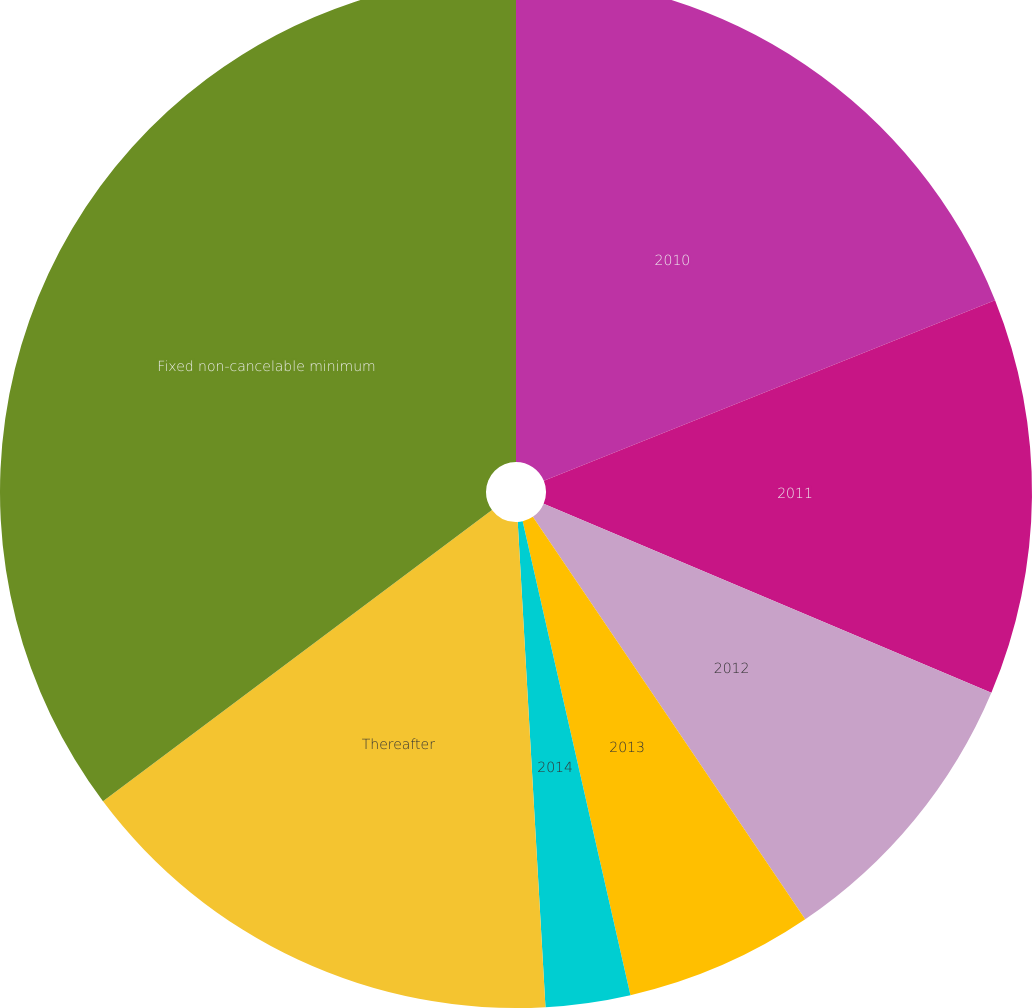Convert chart. <chart><loc_0><loc_0><loc_500><loc_500><pie_chart><fcel>2010<fcel>2011<fcel>2012<fcel>2013<fcel>2014<fcel>Thereafter<fcel>Fixed non-cancelable minimum<nl><fcel>18.94%<fcel>12.42%<fcel>9.17%<fcel>5.91%<fcel>2.65%<fcel>15.68%<fcel>35.23%<nl></chart> 